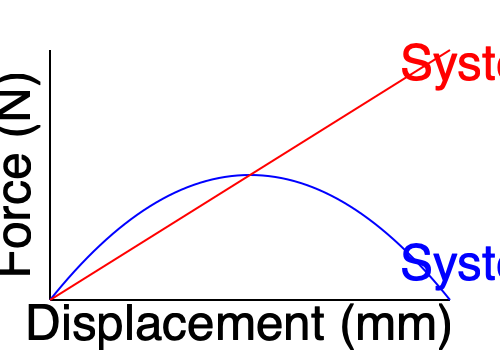The force-displacement graphs for two different suspension systems are shown above. System A (blue curve) represents our company's current suspension design, while System B (red line) represents a new competitor's design. Calculate the difference in energy absorption between these two systems for a displacement of 100 mm. Which system would you recommend for a more comfortable ride, and why? To solve this problem and determine which system provides a more comfortable ride, we need to follow these steps:

1. Understand the relationship between force-displacement graphs and energy absorption:
   - The area under a force-displacement curve represents the energy absorbed by the system.

2. Estimate the force at 100 mm displacement for both systems:
   - System A (blue): Approximately 600 N
   - System B (red): Approximately 400 N

3. Calculate the energy absorbed by each system:
   - System A: Area under the curve ≈ (1/2 * 100 mm * 600 N) = 30,000 N·mm
   - System B: Area under the triangle = (1/2 * 100 mm * 400 N) = 20,000 N·mm

4. Calculate the difference in energy absorption:
   $\text{Difference} = 30,000 \text{ N·mm} - 20,000 \text{ N·mm} = 10,000 \text{ N·mm}$

5. Analyze the results:
   - System A absorbs more energy (10,000 N·mm more) than System B for the same displacement.
   - A suspension system that absorbs more energy generally provides a more comfortable ride by reducing the impact forces transmitted to the rider.

6. Consider the shape of the curves:
   - System A's curve is non-linear, suggesting a progressive spring rate.
   - System B's linear curve indicates a constant spring rate.
   - Progressive spring rates (like System A) typically offer better ride quality by providing softer initial compression and firmer resistance to larger impacts.

Based on this analysis, System A would be recommended for a more comfortable ride because it absorbs more energy and has a progressive spring rate, which better adapts to different road conditions and impact intensities.
Answer: System A; absorbs 10,000 N·mm more energy and has a progressive spring rate. 